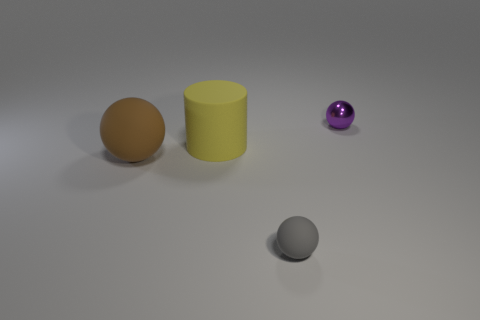Subtract all purple spheres. How many spheres are left? 2 Subtract all small gray matte balls. How many balls are left? 2 Subtract all spheres. How many objects are left? 1 Subtract 1 balls. How many balls are left? 2 Subtract all cyan spheres. Subtract all blue blocks. How many spheres are left? 3 Subtract all gray cylinders. How many cyan spheres are left? 0 Subtract all small balls. Subtract all tiny matte things. How many objects are left? 1 Add 4 purple metallic objects. How many purple metallic objects are left? 5 Add 3 large gray rubber balls. How many large gray rubber balls exist? 3 Add 2 big gray matte cylinders. How many objects exist? 6 